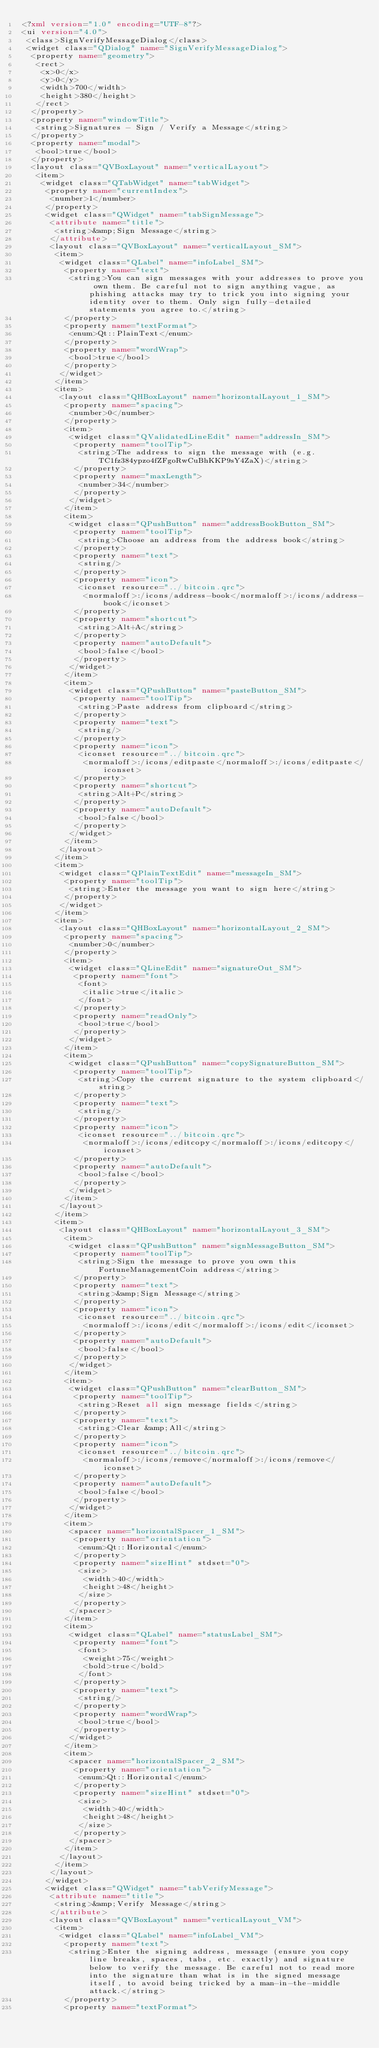<code> <loc_0><loc_0><loc_500><loc_500><_XML_><?xml version="1.0" encoding="UTF-8"?>
<ui version="4.0">
 <class>SignVerifyMessageDialog</class>
 <widget class="QDialog" name="SignVerifyMessageDialog">
  <property name="geometry">
   <rect>
    <x>0</x>
    <y>0</y>
    <width>700</width>
    <height>380</height>
   </rect>
  </property>
  <property name="windowTitle">
   <string>Signatures - Sign / Verify a Message</string>
  </property>
  <property name="modal">
   <bool>true</bool>
  </property>
  <layout class="QVBoxLayout" name="verticalLayout">
   <item>
    <widget class="QTabWidget" name="tabWidget">
     <property name="currentIndex">
      <number>1</number>
     </property>
     <widget class="QWidget" name="tabSignMessage">
      <attribute name="title">
       <string>&amp;Sign Message</string>
      </attribute>
      <layout class="QVBoxLayout" name="verticalLayout_SM">
       <item>
        <widget class="QLabel" name="infoLabel_SM">
         <property name="text">
          <string>You can sign messages with your addresses to prove you own them. Be careful not to sign anything vague, as phishing attacks may try to trick you into signing your identity over to them. Only sign fully-detailed statements you agree to.</string>
         </property>
         <property name="textFormat">
          <enum>Qt::PlainText</enum>
         </property>
         <property name="wordWrap">
          <bool>true</bool>
         </property>
        </widget>
       </item>
       <item>
        <layout class="QHBoxLayout" name="horizontalLayout_1_SM">
         <property name="spacing">
          <number>0</number>
         </property>
         <item>
          <widget class="QValidatedLineEdit" name="addressIn_SM">
           <property name="toolTip">
            <string>The address to sign the message with (e.g. TC1fz384ypzo4fZFgoRwCuBhKKP9sY4ZaX)</string>
           </property>
           <property name="maxLength">
            <number>34</number>
           </property>
          </widget>
         </item>
         <item>
          <widget class="QPushButton" name="addressBookButton_SM">
           <property name="toolTip">
            <string>Choose an address from the address book</string>
           </property>
           <property name="text">
            <string/>
           </property>
           <property name="icon">
            <iconset resource="../bitcoin.qrc">
             <normaloff>:/icons/address-book</normaloff>:/icons/address-book</iconset>
           </property>
           <property name="shortcut">
            <string>Alt+A</string>
           </property>
           <property name="autoDefault">
            <bool>false</bool>
           </property>
          </widget>
         </item>
         <item>
          <widget class="QPushButton" name="pasteButton_SM">
           <property name="toolTip">
            <string>Paste address from clipboard</string>
           </property>
           <property name="text">
            <string/>
           </property>
           <property name="icon">
            <iconset resource="../bitcoin.qrc">
             <normaloff>:/icons/editpaste</normaloff>:/icons/editpaste</iconset>
           </property>
           <property name="shortcut">
            <string>Alt+P</string>
           </property>
           <property name="autoDefault">
            <bool>false</bool>
           </property>
          </widget>
         </item>
        </layout>
       </item>
       <item>
        <widget class="QPlainTextEdit" name="messageIn_SM">
         <property name="toolTip">
          <string>Enter the message you want to sign here</string>
         </property>
        </widget>
       </item>
       <item>
        <layout class="QHBoxLayout" name="horizontalLayout_2_SM">
         <property name="spacing">
          <number>0</number>
         </property>
         <item>
          <widget class="QLineEdit" name="signatureOut_SM">
           <property name="font">
            <font>
             <italic>true</italic>
            </font>
           </property>
           <property name="readOnly">
            <bool>true</bool>
           </property>
          </widget>
         </item>
         <item>
          <widget class="QPushButton" name="copySignatureButton_SM">
           <property name="toolTip">
            <string>Copy the current signature to the system clipboard</string>
           </property>
           <property name="text">
            <string/>
           </property>
           <property name="icon">
            <iconset resource="../bitcoin.qrc">
             <normaloff>:/icons/editcopy</normaloff>:/icons/editcopy</iconset>
           </property>
           <property name="autoDefault">
            <bool>false</bool>
           </property>
          </widget>
         </item>
        </layout>
       </item>
       <item>
        <layout class="QHBoxLayout" name="horizontalLayout_3_SM">
         <item>
          <widget class="QPushButton" name="signMessageButton_SM">
           <property name="toolTip">
            <string>Sign the message to prove you own this FortuneManagementCoin address</string>
           </property>
           <property name="text">
            <string>&amp;Sign Message</string>
           </property>
           <property name="icon">
            <iconset resource="../bitcoin.qrc">
             <normaloff>:/icons/edit</normaloff>:/icons/edit</iconset>
           </property>
           <property name="autoDefault">
            <bool>false</bool>
           </property>
          </widget>
         </item>
         <item>
          <widget class="QPushButton" name="clearButton_SM">
           <property name="toolTip">
            <string>Reset all sign message fields</string>
           </property>
           <property name="text">
            <string>Clear &amp;All</string>
           </property>
           <property name="icon">
            <iconset resource="../bitcoin.qrc">
             <normaloff>:/icons/remove</normaloff>:/icons/remove</iconset>
           </property>
           <property name="autoDefault">
            <bool>false</bool>
           </property>
          </widget>
         </item>
         <item>
          <spacer name="horizontalSpacer_1_SM">
           <property name="orientation">
            <enum>Qt::Horizontal</enum>
           </property>
           <property name="sizeHint" stdset="0">
            <size>
             <width>40</width>
             <height>48</height>
            </size>
           </property>
          </spacer>
         </item>
         <item>
          <widget class="QLabel" name="statusLabel_SM">
           <property name="font">
            <font>
             <weight>75</weight>
             <bold>true</bold>
            </font>
           </property>
           <property name="text">
            <string/>
           </property>
           <property name="wordWrap">
            <bool>true</bool>
           </property>
          </widget>
         </item>
         <item>
          <spacer name="horizontalSpacer_2_SM">
           <property name="orientation">
            <enum>Qt::Horizontal</enum>
           </property>
           <property name="sizeHint" stdset="0">
            <size>
             <width>40</width>
             <height>48</height>
            </size>
           </property>
          </spacer>
         </item>
        </layout>
       </item>
      </layout>
     </widget>
     <widget class="QWidget" name="tabVerifyMessage">
      <attribute name="title">
       <string>&amp;Verify Message</string>
      </attribute>
      <layout class="QVBoxLayout" name="verticalLayout_VM">
       <item>
        <widget class="QLabel" name="infoLabel_VM">
         <property name="text">
          <string>Enter the signing address, message (ensure you copy line breaks, spaces, tabs, etc. exactly) and signature below to verify the message. Be careful not to read more into the signature than what is in the signed message itself, to avoid being tricked by a man-in-the-middle attack.</string>
         </property>
         <property name="textFormat"></code> 